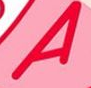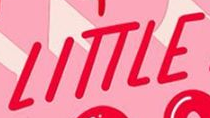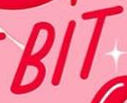Identify the words shown in these images in order, separated by a semicolon. A; LITTLE; BIT 